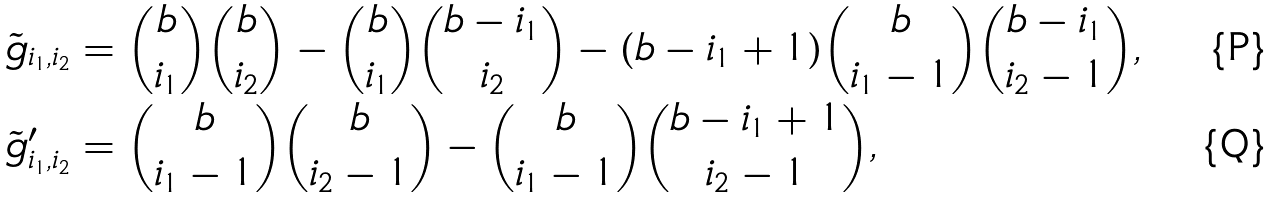<formula> <loc_0><loc_0><loc_500><loc_500>\tilde { g } _ { i _ { 1 } , i _ { 2 } } & = \binom { b } { i _ { 1 } } \binom { b } { i _ { 2 } } - \binom { b } { i _ { 1 } } \binom { b - i _ { 1 } } { i _ { 2 } } - ( b - i _ { 1 } + 1 ) \binom { b } { i _ { 1 } - 1 } \binom { b - i _ { 1 } } { i _ { 2 } - 1 } , \\ \tilde { g } ^ { \prime } _ { i _ { 1 } , i _ { 2 } } & = \binom { b } { i _ { 1 } - 1 } \binom { b } { i _ { 2 } - 1 } - \binom { b } { i _ { 1 } - 1 } \binom { b - i _ { 1 } + 1 } { i _ { 2 } - 1 } ,</formula> 